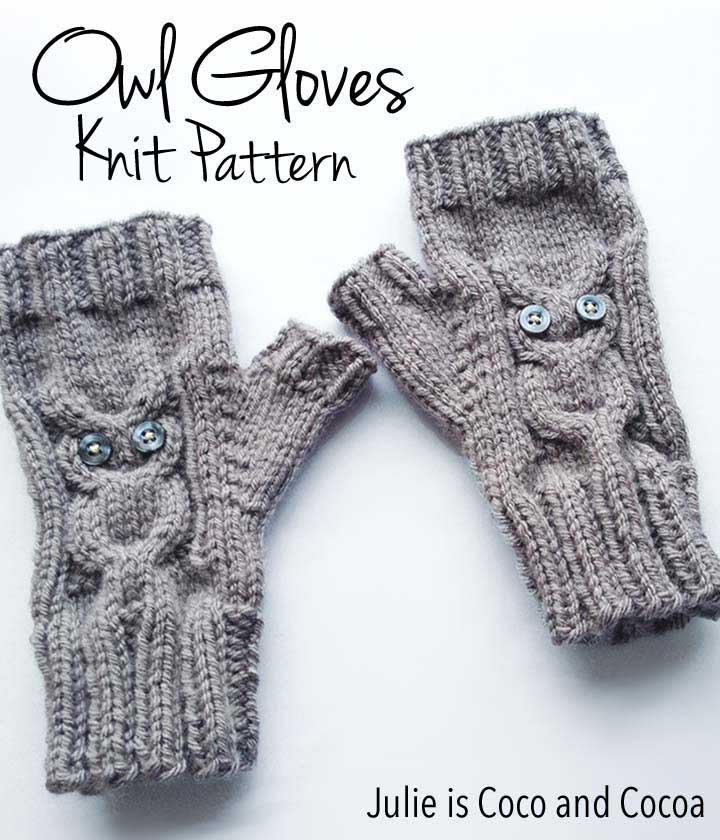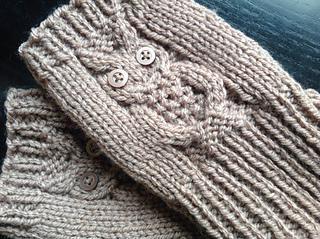The first image is the image on the left, the second image is the image on the right. Evaluate the accuracy of this statement regarding the images: "Four hands have gloves on them.". Is it true? Answer yes or no. No. The first image is the image on the left, the second image is the image on the right. For the images displayed, is the sentence "The right image is of two hands wearing turquoise fingerless mittens." factually correct? Answer yes or no. No. 